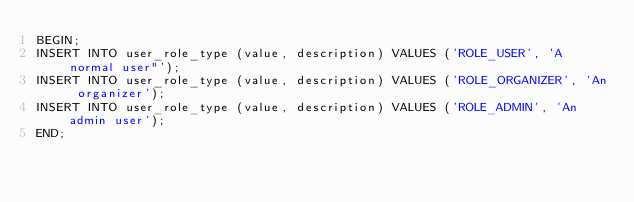<code> <loc_0><loc_0><loc_500><loc_500><_SQL_>BEGIN;
INSERT INTO user_role_type (value, description) VALUES ('ROLE_USER', 'A normal user"');
INSERT INTO user_role_type (value, description) VALUES ('ROLE_ORGANIZER', 'An organizer');
INSERT INTO user_role_type (value, description) VALUES ('ROLE_ADMIN', 'An admin user');
END;</code> 